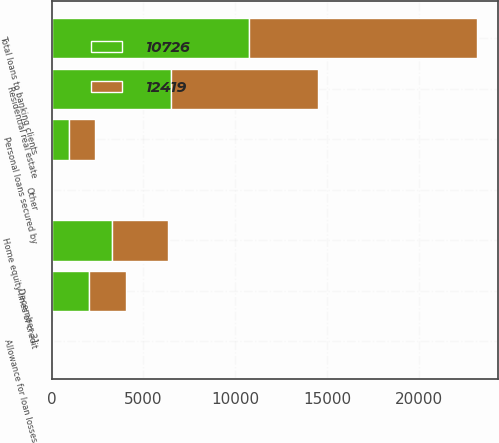<chart> <loc_0><loc_0><loc_500><loc_500><stacked_bar_chart><ecel><fcel>December 31<fcel>Residential real estate<fcel>Home equity lines of credit<fcel>Personal loans secured by<fcel>Other<fcel>Total loans to banking clients<fcel>Allowance for loan losses<nl><fcel>12419<fcel>2013<fcel>8006<fcel>3041<fcel>1384<fcel>36<fcel>12419<fcel>48<nl><fcel>10726<fcel>2012<fcel>6507<fcel>3287<fcel>963<fcel>25<fcel>10726<fcel>56<nl></chart> 